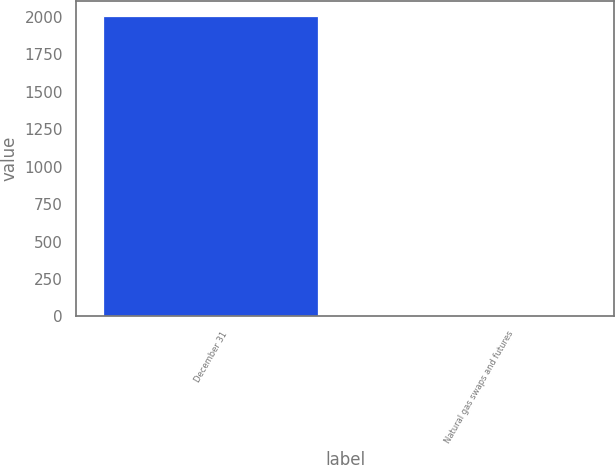Convert chart to OTSL. <chart><loc_0><loc_0><loc_500><loc_500><bar_chart><fcel>December 31<fcel>Natural gas swaps and futures<nl><fcel>2007<fcel>1<nl></chart> 